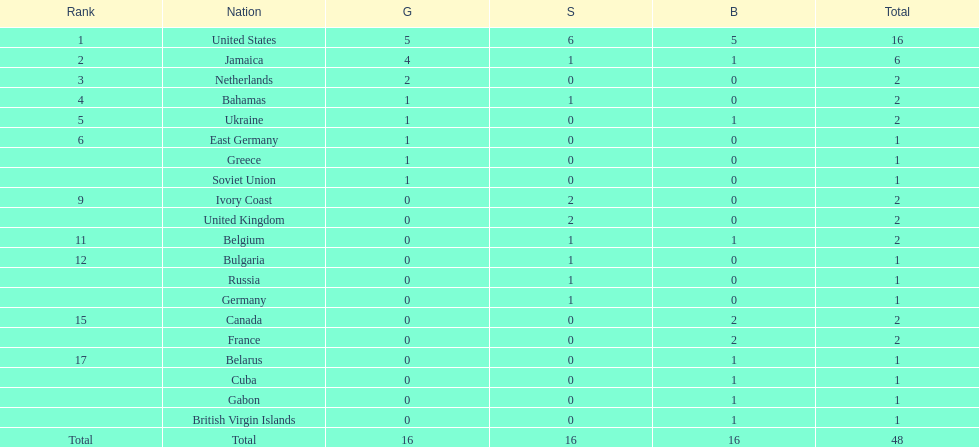What is the average number of gold medals won by the top 5 nations? 2.6. 